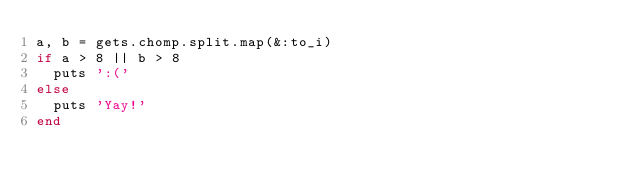<code> <loc_0><loc_0><loc_500><loc_500><_Ruby_>a, b = gets.chomp.split.map(&:to_i)
if a > 8 || b > 8
  puts ':('
else
  puts 'Yay!'
end</code> 